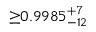Convert formula to latex. <formula><loc_0><loc_0><loc_500><loc_500>{ \geq } 0 . 9 9 8 5 _ { - 1 2 } ^ { + 7 }</formula> 